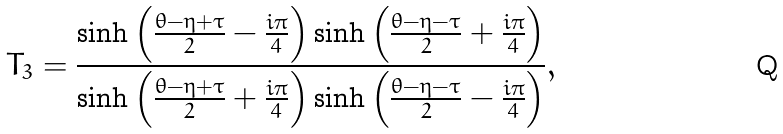Convert formula to latex. <formula><loc_0><loc_0><loc_500><loc_500>T _ { 3 } = \frac { \sinh \left ( \frac { \theta - \eta + \tau } { 2 } - \frac { i \pi } { 4 } \right ) \sinh \left ( \frac { \theta - \eta - \tau } { 2 } + \frac { i \pi } { 4 } \right ) } { \sinh \left ( \frac { \theta - \eta + \tau } { 2 } + \frac { i \pi } { 4 } \right ) \sinh \left ( \frac { \theta - \eta - \tau } { 2 } - \frac { i \pi } { 4 } \right ) } ,</formula> 